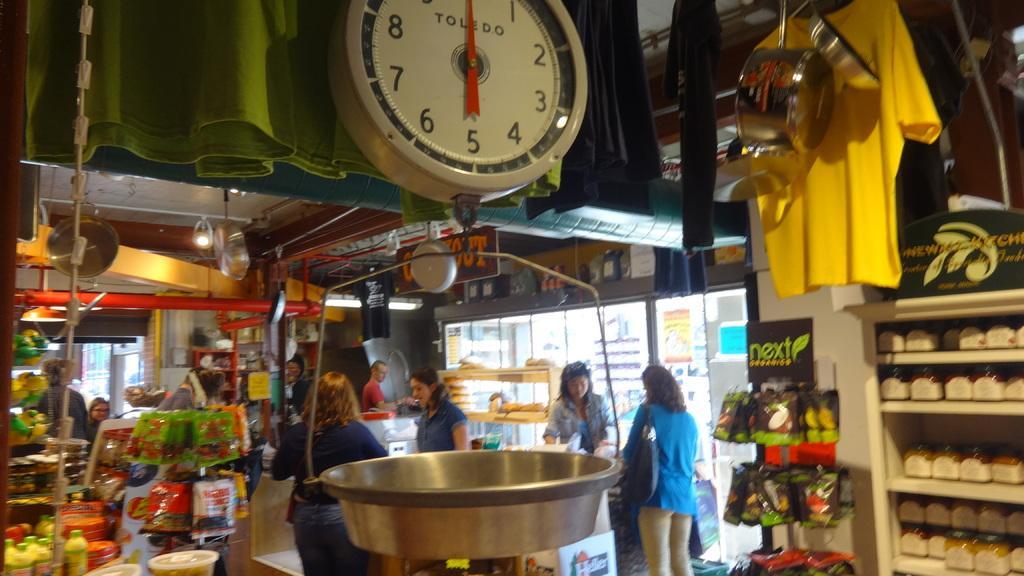Can you describe this image briefly? In this image there is a grocery store, in that there are grocery items, in the middle there is a weighing machine and there are people. 